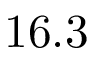<formula> <loc_0><loc_0><loc_500><loc_500>1 6 . 3</formula> 